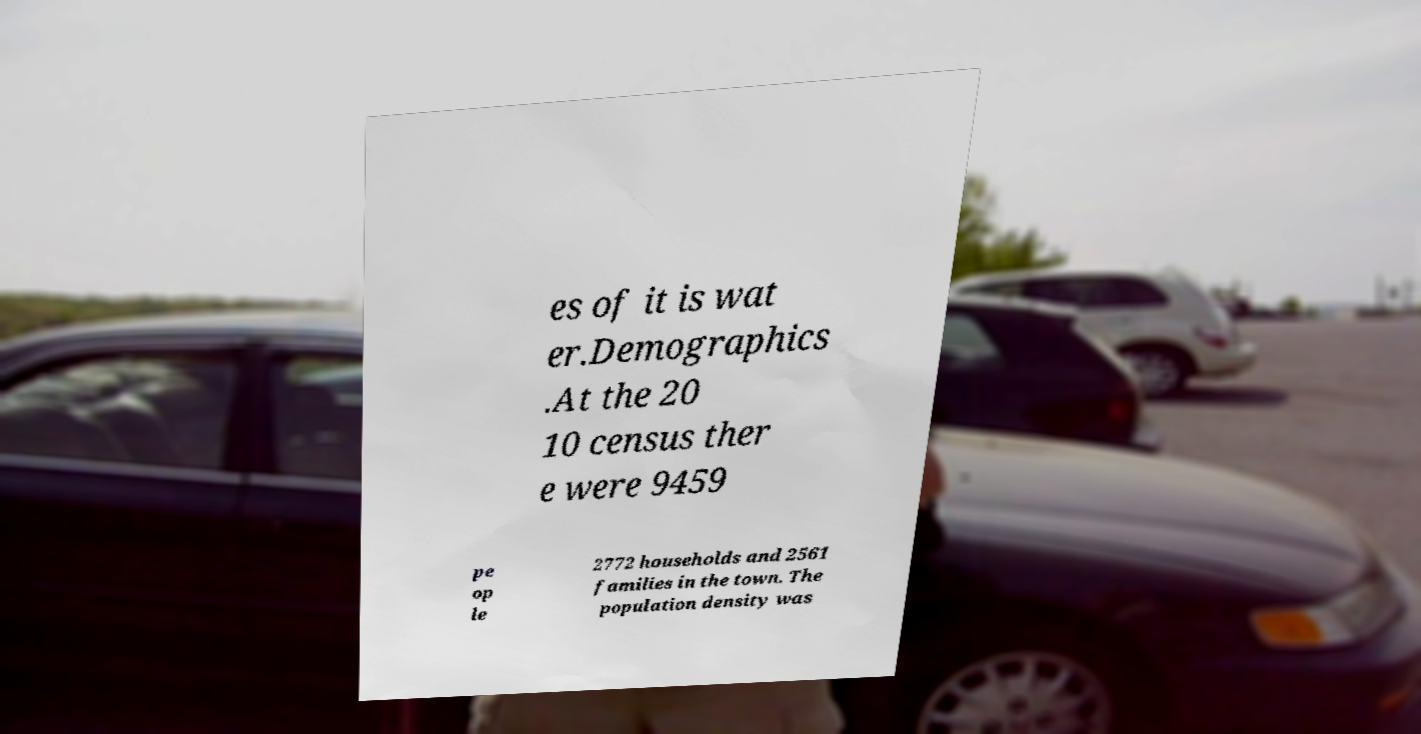Can you read and provide the text displayed in the image?This photo seems to have some interesting text. Can you extract and type it out for me? es of it is wat er.Demographics .At the 20 10 census ther e were 9459 pe op le 2772 households and 2561 families in the town. The population density was 